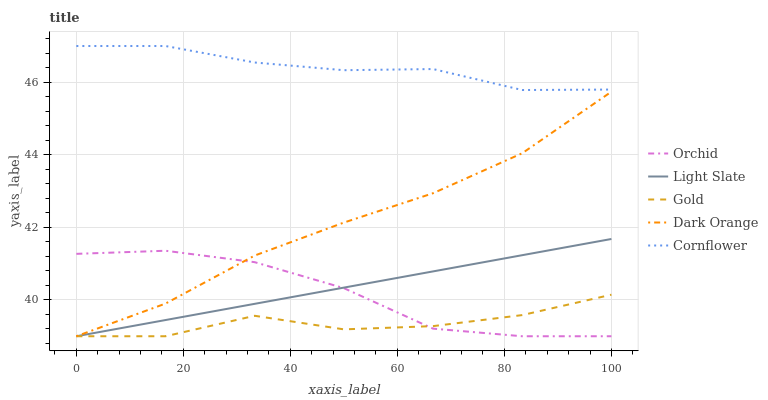Does Dark Orange have the minimum area under the curve?
Answer yes or no. No. Does Dark Orange have the maximum area under the curve?
Answer yes or no. No. Is Dark Orange the smoothest?
Answer yes or no. No. Is Dark Orange the roughest?
Answer yes or no. No. Does Cornflower have the lowest value?
Answer yes or no. No. Does Dark Orange have the highest value?
Answer yes or no. No. Is Gold less than Cornflower?
Answer yes or no. Yes. Is Cornflower greater than Orchid?
Answer yes or no. Yes. Does Gold intersect Cornflower?
Answer yes or no. No. 